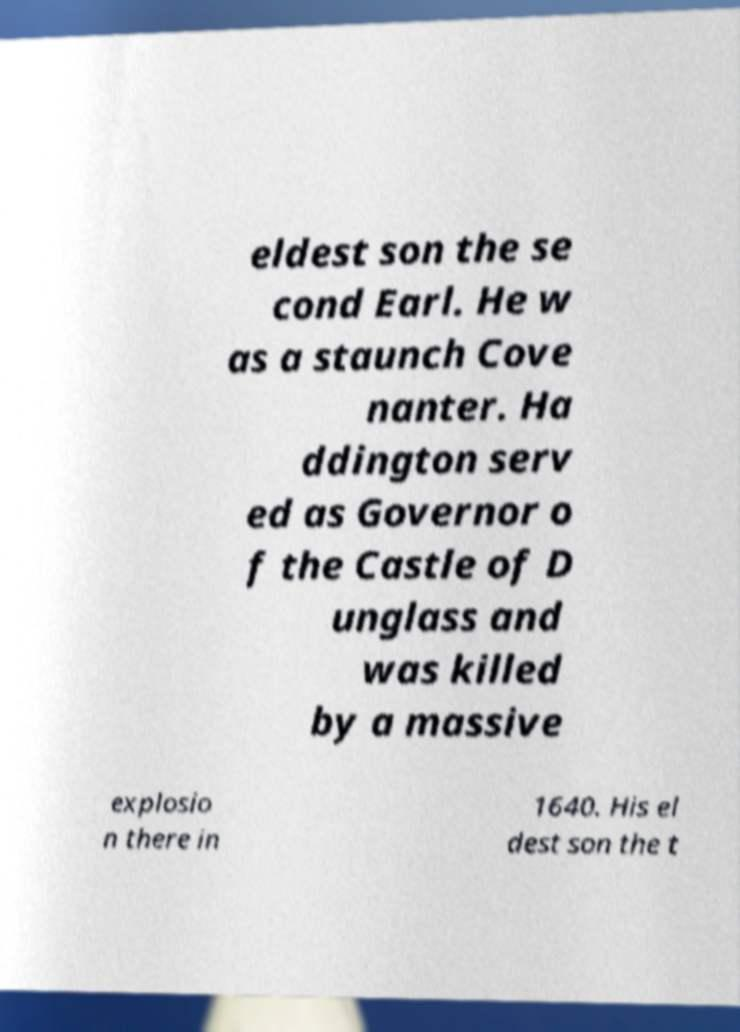Can you accurately transcribe the text from the provided image for me? eldest son the se cond Earl. He w as a staunch Cove nanter. Ha ddington serv ed as Governor o f the Castle of D unglass and was killed by a massive explosio n there in 1640. His el dest son the t 